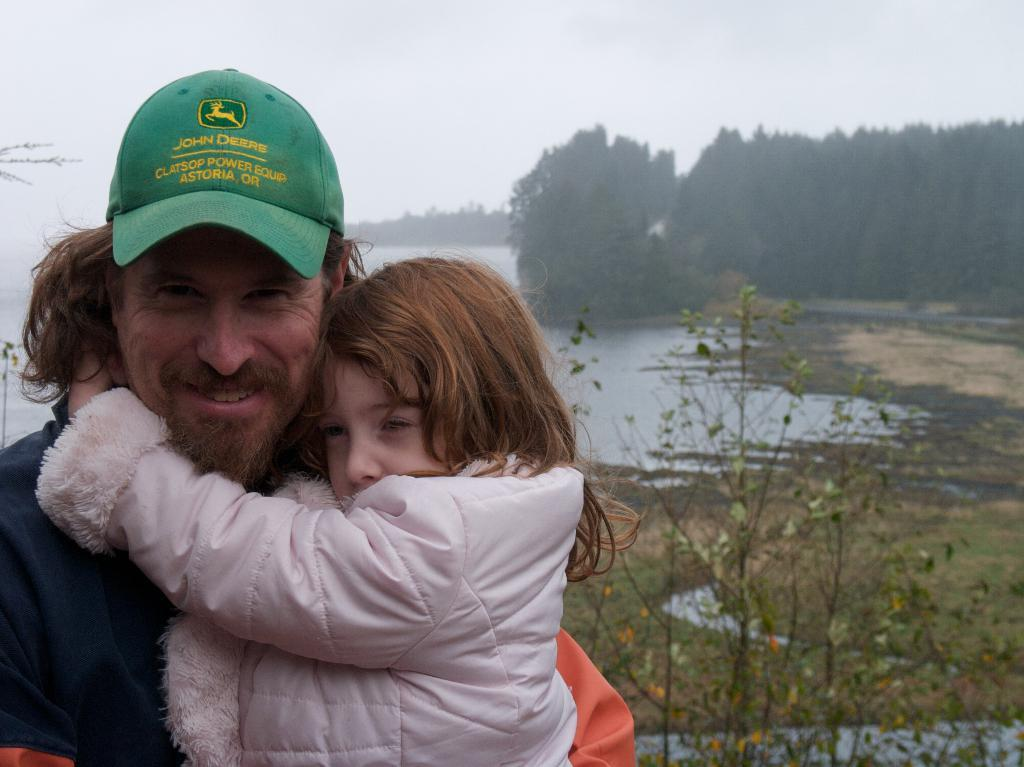What is the person in the image doing with the baby? The person is holding a baby in the image. What is the facial expression of the person holding the baby? The person is smiling. What can be seen in the background of the image? There is sky, a tree, and a lake visible in the background of the image. What type of vegetation is present at the bottom of the image? There is a plant at the bottom of the image. What language is the baby speaking in the image? The image does not provide any information about the language spoken by the baby. --- 